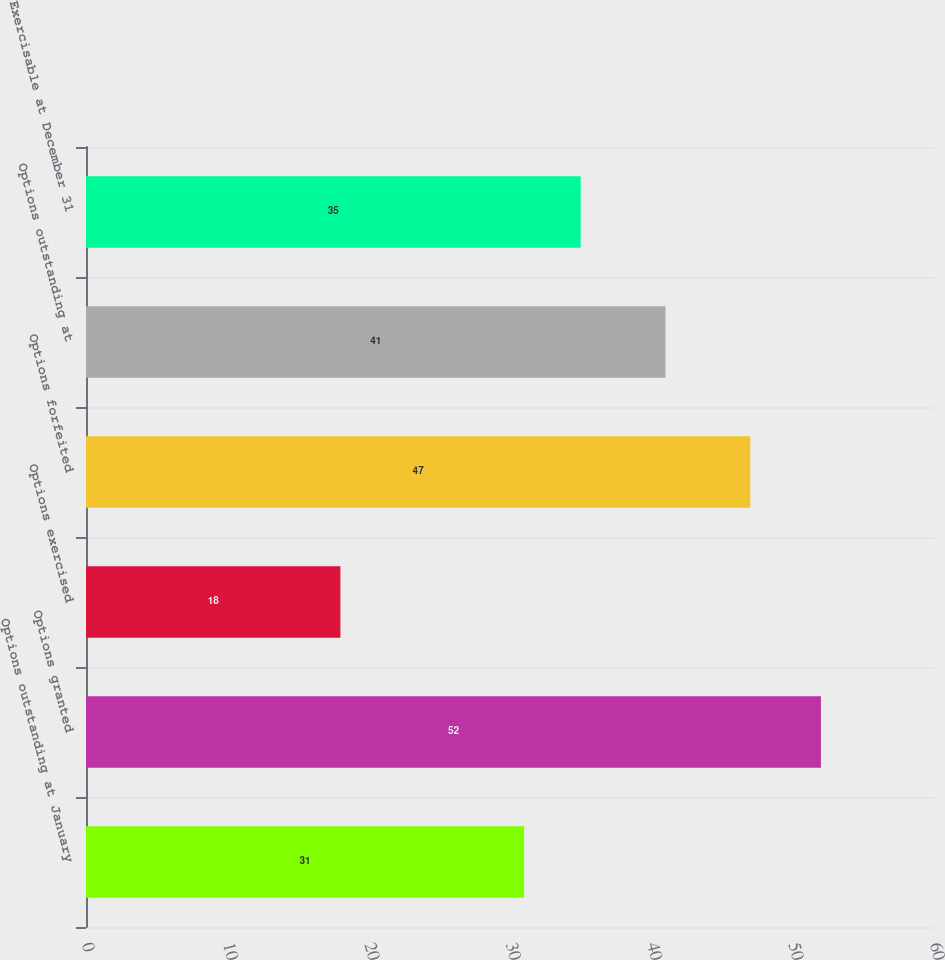<chart> <loc_0><loc_0><loc_500><loc_500><bar_chart><fcel>Options outstanding at January<fcel>Options granted<fcel>Options exercised<fcel>Options forfeited<fcel>Options outstanding at<fcel>Exercisable at December 31<nl><fcel>31<fcel>52<fcel>18<fcel>47<fcel>41<fcel>35<nl></chart> 